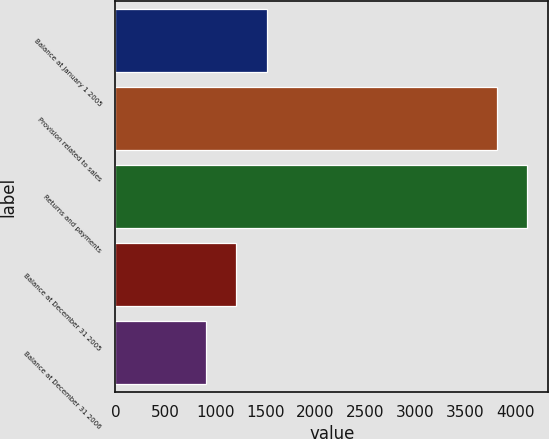Convert chart. <chart><loc_0><loc_0><loc_500><loc_500><bar_chart><fcel>Balance at January 1 2005<fcel>Provision related to sales<fcel>Returns and payments<fcel>Balance at December 31 2005<fcel>Balance at December 31 2006<nl><fcel>1512.2<fcel>3817<fcel>4121.1<fcel>1208.1<fcel>904<nl></chart> 